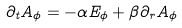<formula> <loc_0><loc_0><loc_500><loc_500>\partial _ { t } A _ { \phi } = - \alpha E _ { \phi } + \beta \partial _ { r } A _ { \phi }</formula> 